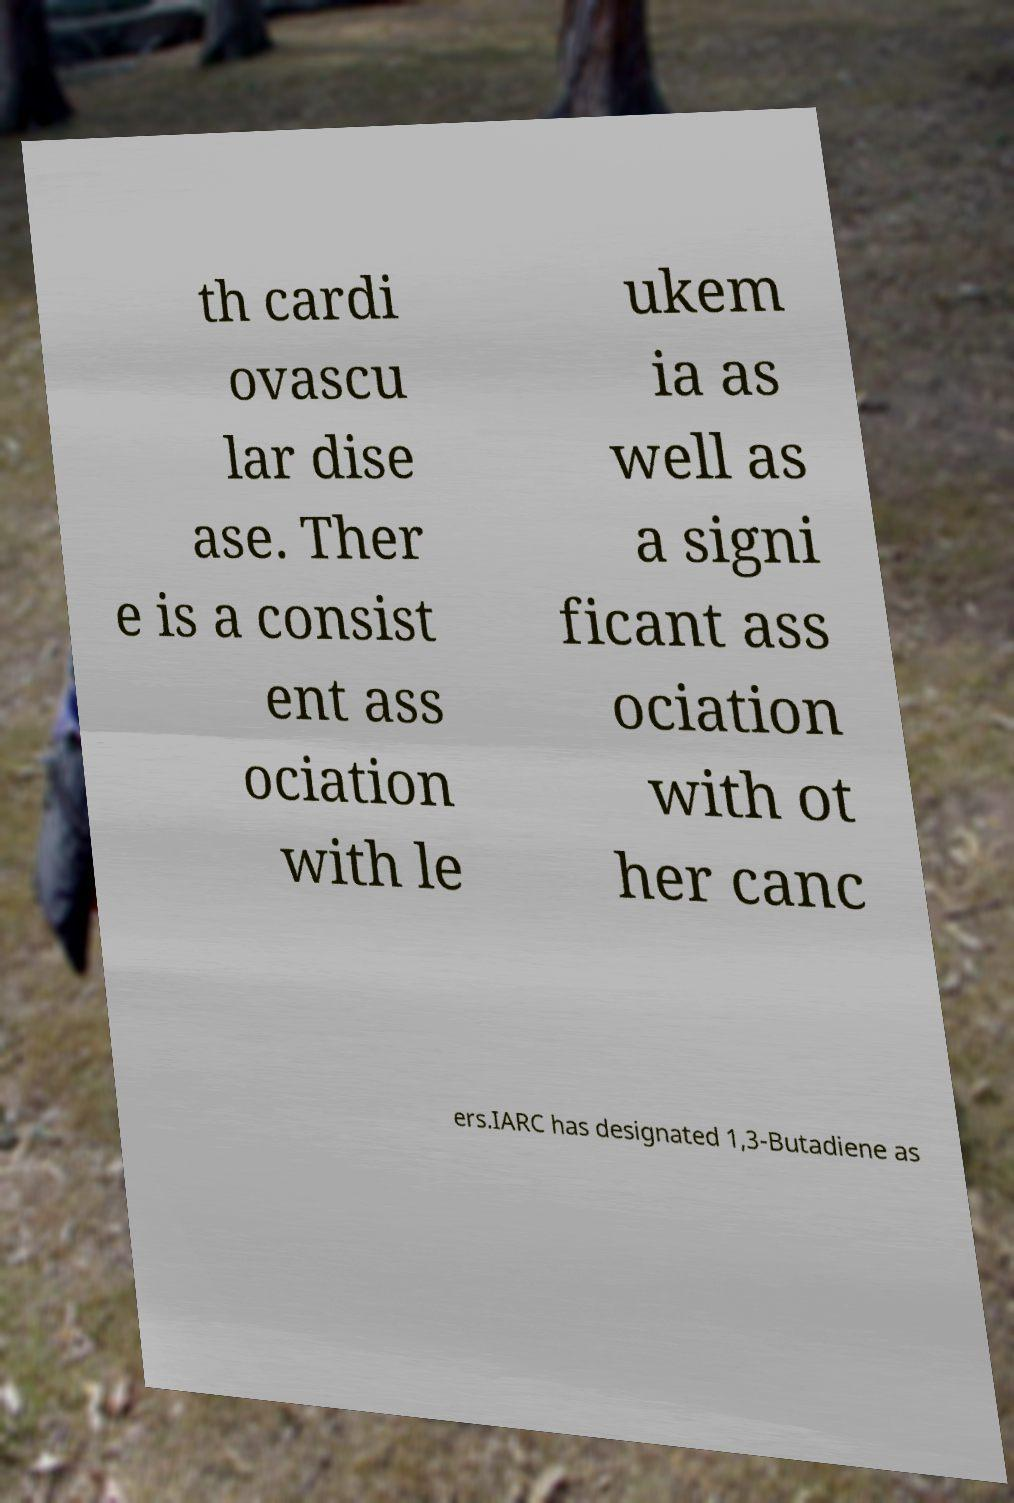Could you extract and type out the text from this image? th cardi ovascu lar dise ase. Ther e is a consist ent ass ociation with le ukem ia as well as a signi ficant ass ociation with ot her canc ers.IARC has designated 1,3-Butadiene as 